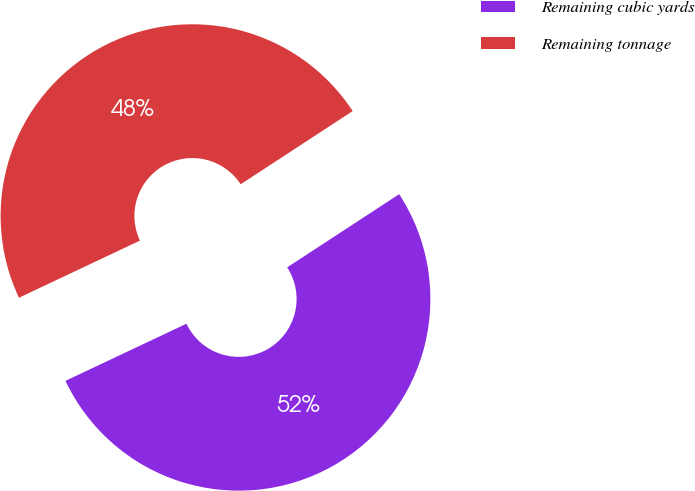<chart> <loc_0><loc_0><loc_500><loc_500><pie_chart><fcel>Remaining cubic yards<fcel>Remaining tonnage<nl><fcel>52.19%<fcel>47.81%<nl></chart> 